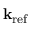Convert formula to latex. <formula><loc_0><loc_0><loc_500><loc_500>k _ { r e f }</formula> 